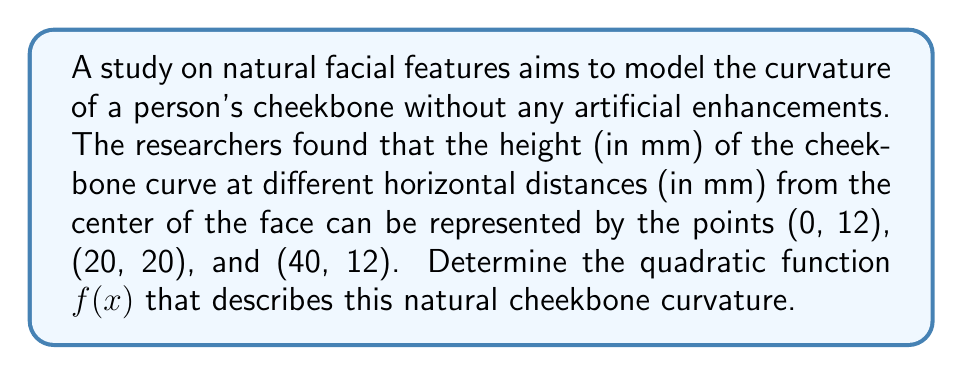Give your solution to this math problem. To find the quadratic function $f(x) = ax^2 + bx + c$ that fits the given points, we'll use the following steps:

1) We have three points: (0, 12), (20, 20), and (40, 12). Let's substitute these into the general form of a quadratic equation:

   12 = a(0)^2 + b(0) + c
   20 = a(20)^2 + b(20) + c
   12 = a(40)^2 + b(40) + c

2) Simplify:

   12 = c                    (Equation 1)
   20 = 400a + 20b + c       (Equation 2)
   12 = 1600a + 40b + c      (Equation 3)

3) Subtract Equation 1 from Equation 2 and Equation 3:

   8 = 400a + 20b            (Equation 4)
   0 = 1600a + 40b           (Equation 5)

4) Divide Equation 5 by 40:

   0 = 40a + b               (Equation 6)

5) Solve for b in terms of a:

   b = -40a

6) Substitute this into Equation 4:

   8 = 400a + 20(-40a)
   8 = 400a - 800a
   8 = -400a
   a = -1/50 = -0.02

7) Find b:

   b = -40(-0.02) = 0.8

8) We already know c = 12 from Equation 1

Therefore, the quadratic function is:

$$f(x) = -0.02x^2 + 0.8x + 12$$

This function represents the natural curvature of the cheekbone without any artificial enhancements, emphasizing the beauty of natural facial features.
Answer: $f(x) = -0.02x^2 + 0.8x + 12$ 